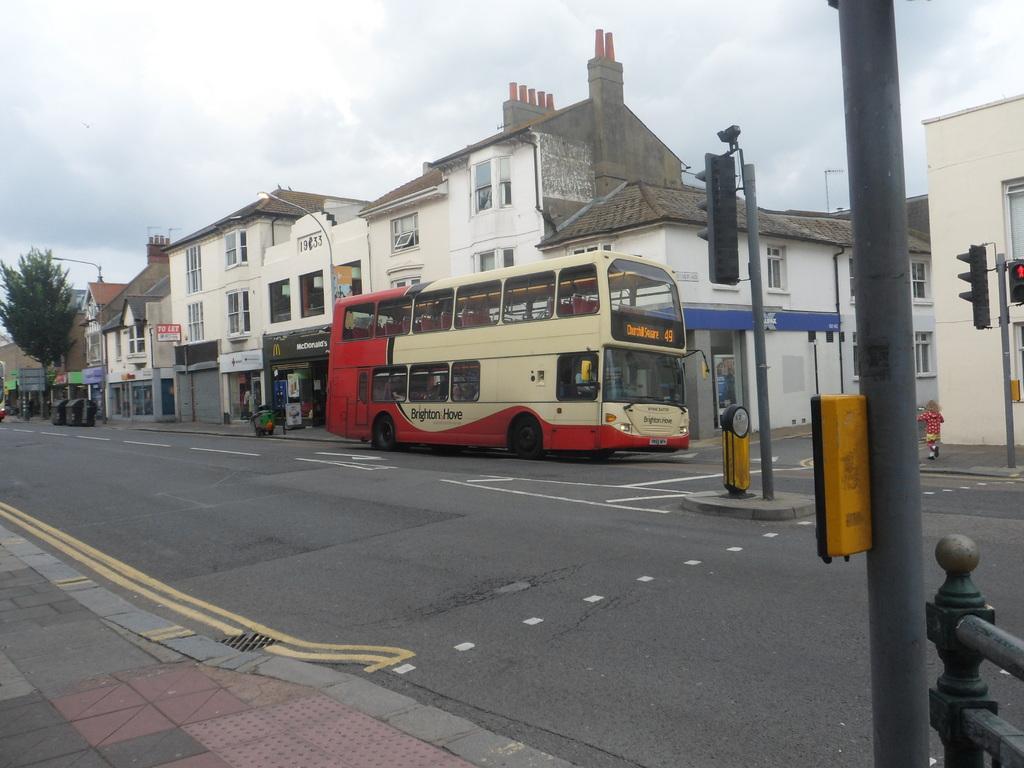How would you summarize this image in a sentence or two? In this image I can see the sidewalk, the road, few poles, few traffic signals, few persons on the sidewalk, a bus which is red, cream and black in color, few buildings and a tree. I can see few black colored bins and in the background I can see the sky. 